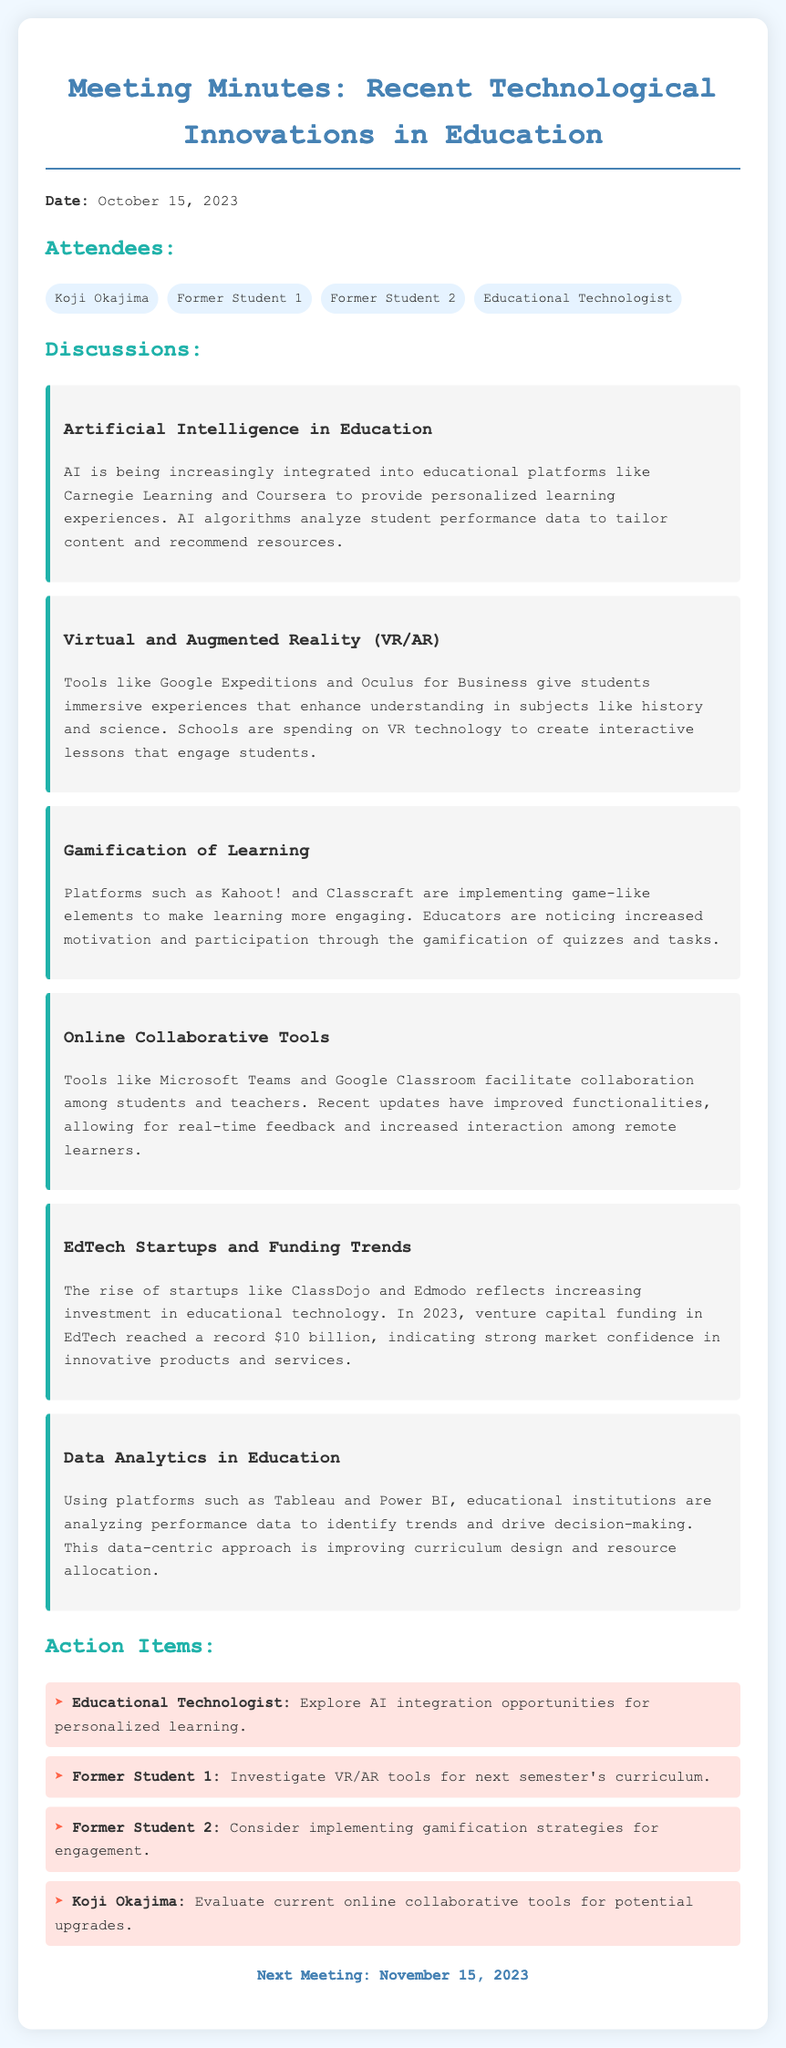What is the date of the meeting? The date of the meeting is clearly stated at the beginning of the document.
Answer: October 15, 2023 Who is one of the attendees? The attendees are listed under the "Attendees" section of the document.
Answer: Koji Okajima What is the focus of the discussion on Artificial Intelligence? The discussion item provides a key focus of AI integration in education.
Answer: Personalized learning experiences What funding amount was reached in EdTech in 2023? The document states the total venture capital funding reached in EdTech in 2023.
Answer: $10 billion Which platform is mentioned for online collaboration? The document mentions specific tools used for collaboration among students and teachers.
Answer: Microsoft Teams What is an action item for Former Student 1? The action items list specific tasks assigned to each attendee.
Answer: Investigate VR/AR tools What technology is being used to analyze performance data in education? The document specifies platforms that institutions use for data analysis.
Answer: Tableau Which technology enhances understanding in subjects like history and science? The document highlights specific technologies that provide immersive learning experiences.
Answer: Virtual and Augmented Reality (VR/AR) 